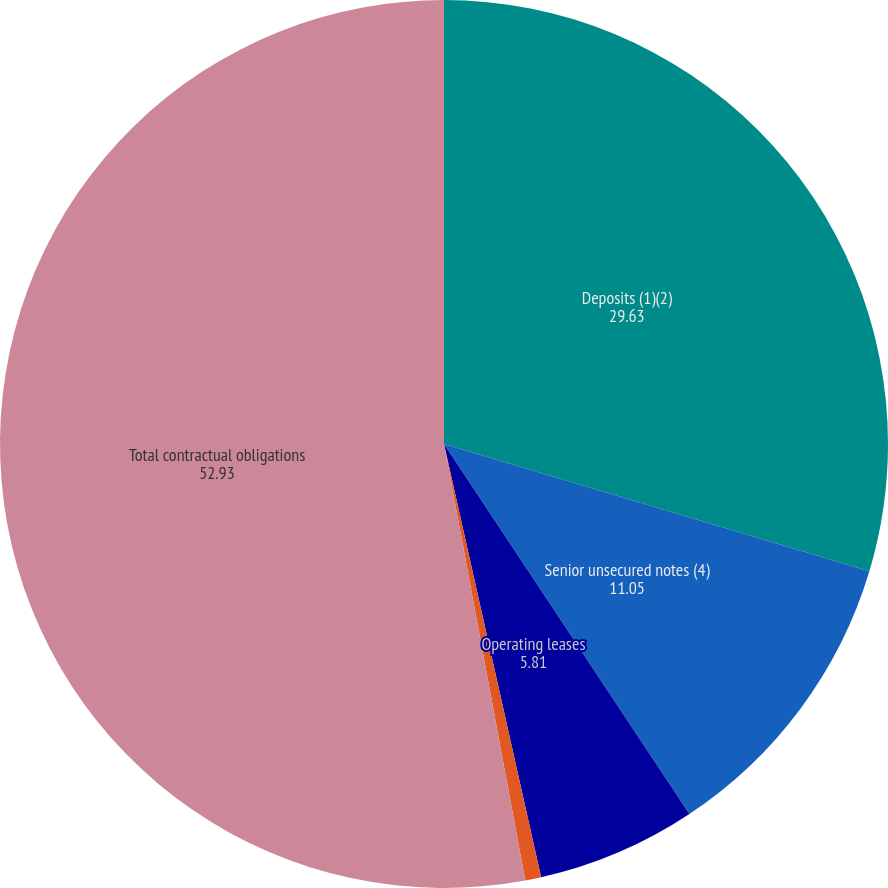Convert chart to OTSL. <chart><loc_0><loc_0><loc_500><loc_500><pie_chart><fcel>Deposits (1)(2)<fcel>Senior unsecured notes (4)<fcel>Operating leases<fcel>Purchase obligations (5)<fcel>Total contractual obligations<nl><fcel>29.63%<fcel>11.05%<fcel>5.81%<fcel>0.58%<fcel>52.93%<nl></chart> 